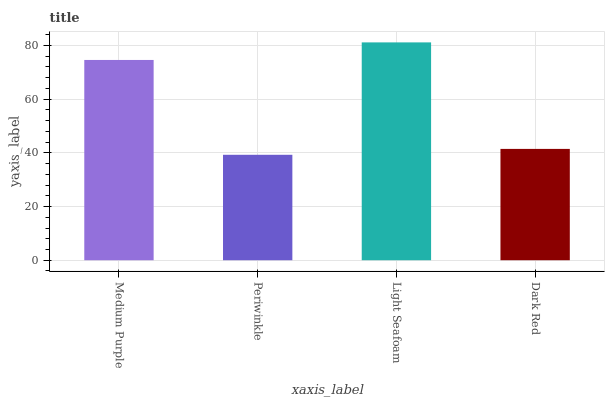Is Periwinkle the minimum?
Answer yes or no. Yes. Is Light Seafoam the maximum?
Answer yes or no. Yes. Is Light Seafoam the minimum?
Answer yes or no. No. Is Periwinkle the maximum?
Answer yes or no. No. Is Light Seafoam greater than Periwinkle?
Answer yes or no. Yes. Is Periwinkle less than Light Seafoam?
Answer yes or no. Yes. Is Periwinkle greater than Light Seafoam?
Answer yes or no. No. Is Light Seafoam less than Periwinkle?
Answer yes or no. No. Is Medium Purple the high median?
Answer yes or no. Yes. Is Dark Red the low median?
Answer yes or no. Yes. Is Dark Red the high median?
Answer yes or no. No. Is Light Seafoam the low median?
Answer yes or no. No. 